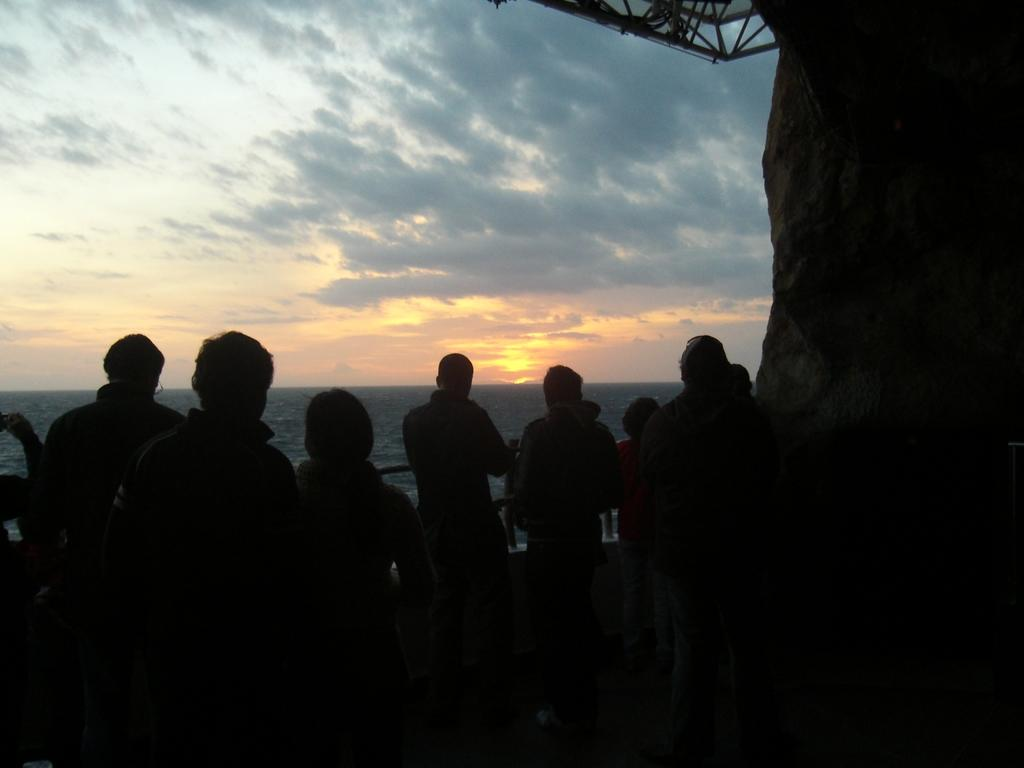Who or what can be seen in the image? There are persons visible in the image. What is visible in the background of the image? The sky is visible in the image. What specific feature of the sky can be observed in the image? A sunset is visible in the image. Can you see a frog jumping in the image? No, there is no frog visible in the image. Is the image set in space? No, the image is not set in space; it features persons and a sunset, which are terrestrial elements. 